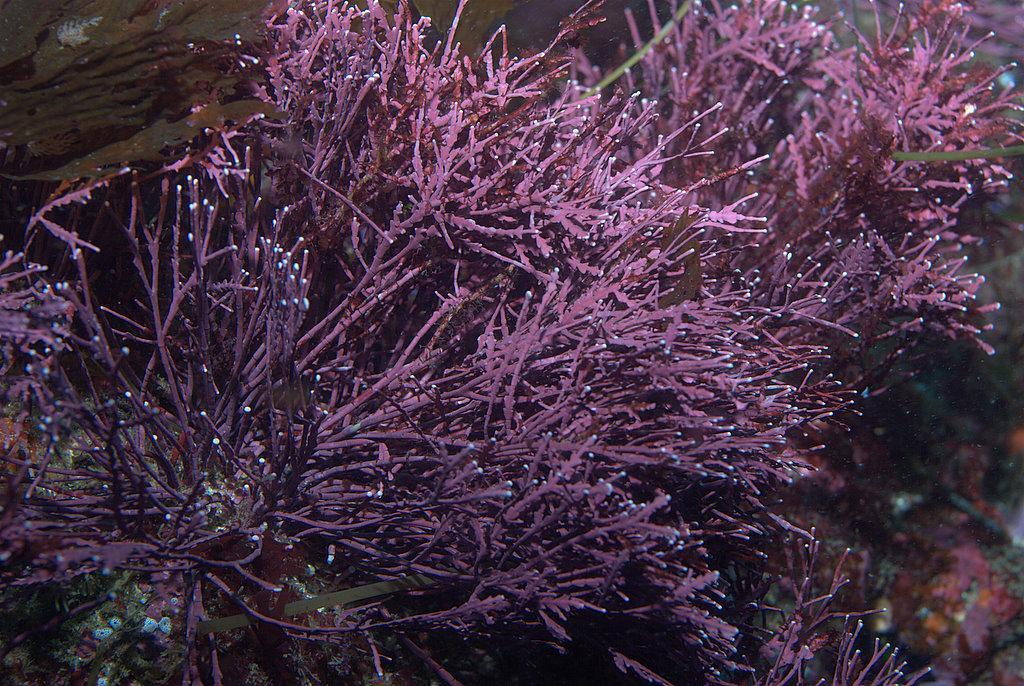Describe this image in one or two sentences. In this image I can see few plants which are pink and green in color and in the background I can see few other objects which are pink, orange and white in color. 